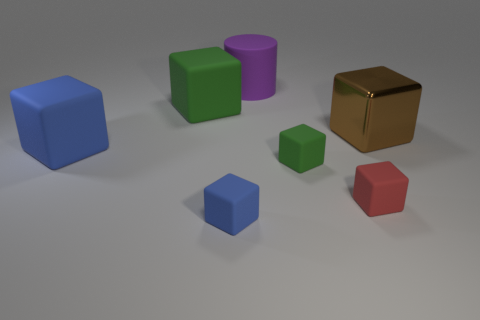How many brown metallic objects are there?
Provide a short and direct response. 1. The purple thing right of the blue thing that is left of the big matte cube behind the big blue rubber cube is what shape?
Provide a short and direct response. Cylinder. Are there fewer green rubber things behind the red thing than big rubber cylinders that are in front of the tiny blue rubber object?
Provide a succinct answer. No. Does the small blue matte object that is left of the purple rubber cylinder have the same shape as the large blue rubber thing behind the small red rubber cube?
Your answer should be very brief. Yes. The blue rubber object that is on the right side of the green block on the left side of the small blue matte cube is what shape?
Give a very brief answer. Cube. Are there any cylinders made of the same material as the small blue block?
Make the answer very short. Yes. There is a large brown object that is in front of the purple cylinder; what is its material?
Give a very brief answer. Metal. What is the material of the small blue block?
Provide a succinct answer. Rubber. Is the material of the blue cube in front of the tiny green rubber object the same as the small green object?
Make the answer very short. Yes. Are there fewer green rubber cubes that are to the right of the big green matte object than matte cylinders?
Give a very brief answer. No. 